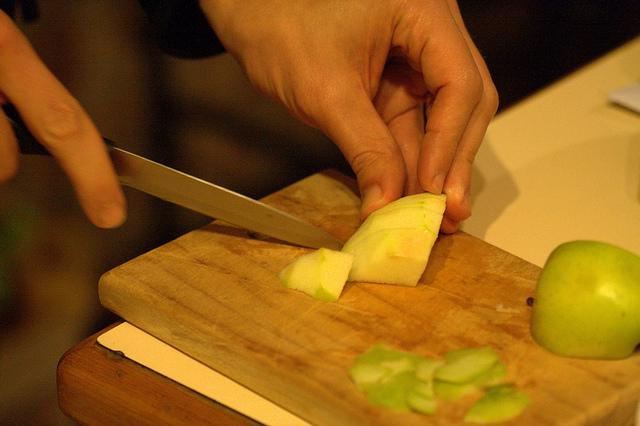What is this type of apple called? Please explain your reasoning. granny smith. The color green is color for certain fruits. it is often used in pies or eaten raw. 